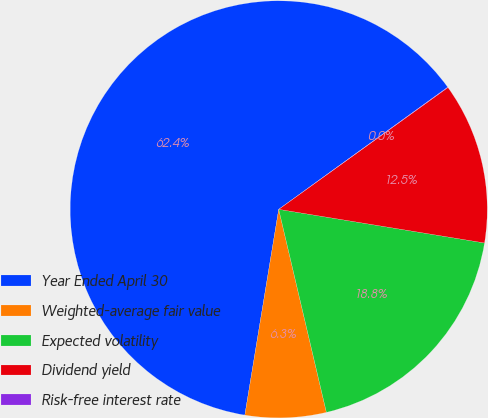<chart> <loc_0><loc_0><loc_500><loc_500><pie_chart><fcel>Year Ended April 30<fcel>Weighted-average fair value<fcel>Expected volatility<fcel>Dividend yield<fcel>Risk-free interest rate<nl><fcel>62.44%<fcel>6.27%<fcel>18.75%<fcel>12.51%<fcel>0.03%<nl></chart> 